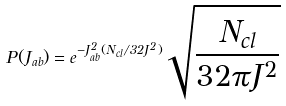Convert formula to latex. <formula><loc_0><loc_0><loc_500><loc_500>P ( J _ { a b } ) = e ^ { - J _ { a b } ^ { 2 } ( N _ { c l } / 3 2 J ^ { 2 } ) } \sqrt { \frac { N _ { c l } } { 3 2 \pi J ^ { 2 } } }</formula> 